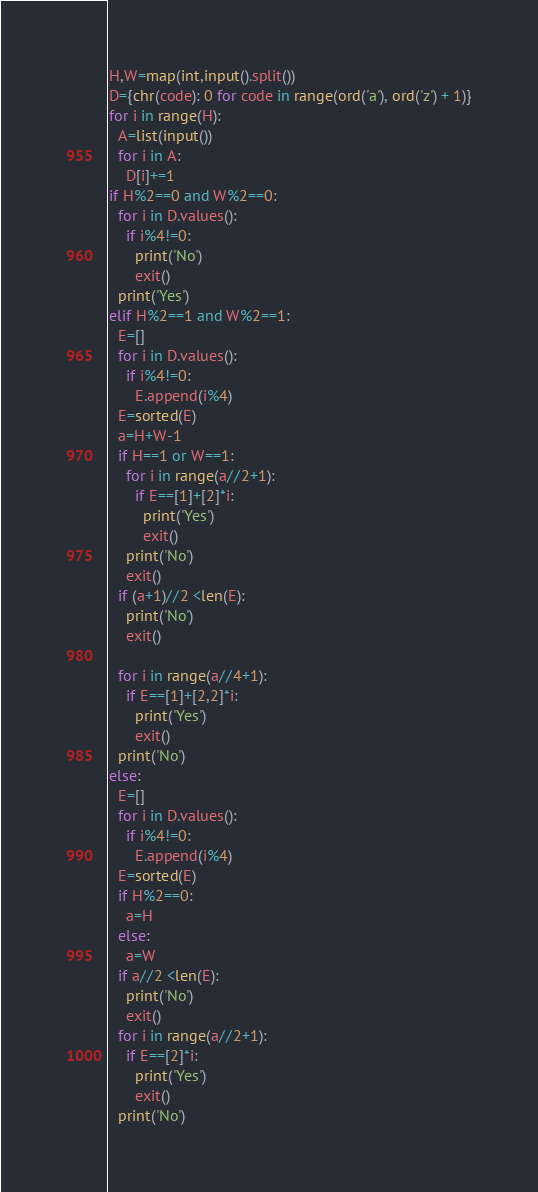<code> <loc_0><loc_0><loc_500><loc_500><_Python_>H,W=map(int,input().split())
D={chr(code): 0 for code in range(ord('a'), ord('z') + 1)}
for i in range(H):
  A=list(input())
  for i in A:
    D[i]+=1
if H%2==0 and W%2==0:
  for i in D.values():
    if i%4!=0:
      print('No')
      exit()
  print('Yes')
elif H%2==1 and W%2==1:
  E=[]
  for i in D.values():
    if i%4!=0:
      E.append(i%4)
  E=sorted(E)
  a=H+W-1
  if H==1 or W==1:
    for i in range(a//2+1):
      if E==[1]+[2]*i:
        print('Yes')
        exit()
    print('No')
    exit()    
  if (a+1)//2 <len(E):
    print('No')
    exit()
  
  for i in range(a//4+1):
    if E==[1]+[2,2]*i:
      print('Yes')
      exit()
  print('No')
else:
  E=[]
  for i in D.values():
    if i%4!=0:
      E.append(i%4)
  E=sorted(E)
  if H%2==0:
    a=H
  else:
    a=W
  if a//2 <len(E):
    print('No')
    exit()
  for i in range(a//2+1):
    if E==[2]*i:
      print('Yes')
      exit()
  print('No')</code> 